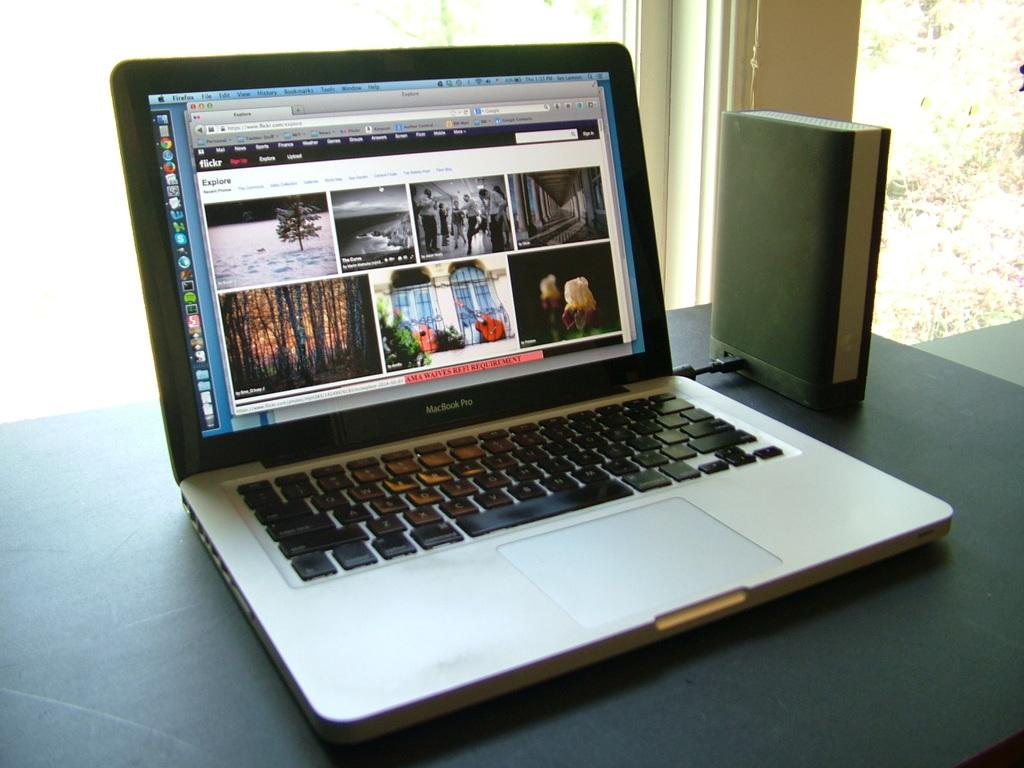<image>
Write a terse but informative summary of the picture. Black and silver Macbook Pro showing some guitars by a window. 